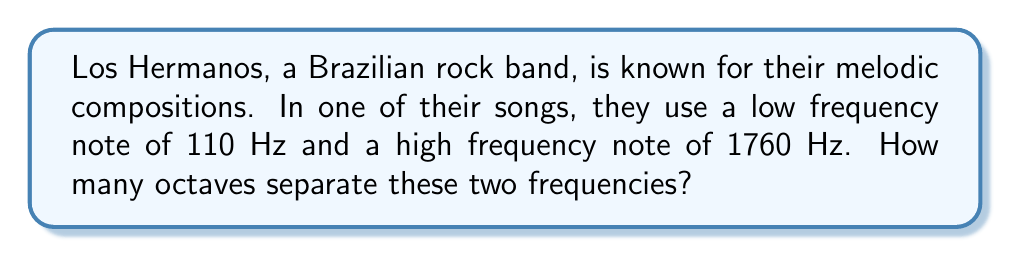Teach me how to tackle this problem. To solve this problem, we need to understand that an octave represents a doubling of frequency. We can use logarithms to calculate the number of octaves between two frequencies.

The formula to find the number of octaves between two frequencies is:

$$ \text{Number of octaves} = \log_2\left(\frac{f_2}{f_1}\right) $$

Where $f_2$ is the higher frequency and $f_1$ is the lower frequency.

Let's plug in our values:

$f_1 = 110$ Hz (lower frequency)
$f_2 = 1760$ Hz (higher frequency)

$$ \text{Number of octaves} = \log_2\left(\frac{1760}{110}\right) $$

To solve this, we can use the change of base formula:

$$ \log_2(x) = \frac{\log(x)}{\log(2)} $$

Applying this to our problem:

$$ \text{Number of octaves} = \frac{\log(1760/110)}{\log(2)} $$

$$ = \frac{\log(16)}{\log(2)} $$

$$ = \frac{4\log(2)}{\log(2)} $$

$$ = 4 $$

Therefore, there are 4 octaves between 110 Hz and 1760 Hz.
Answer: 4 octaves 